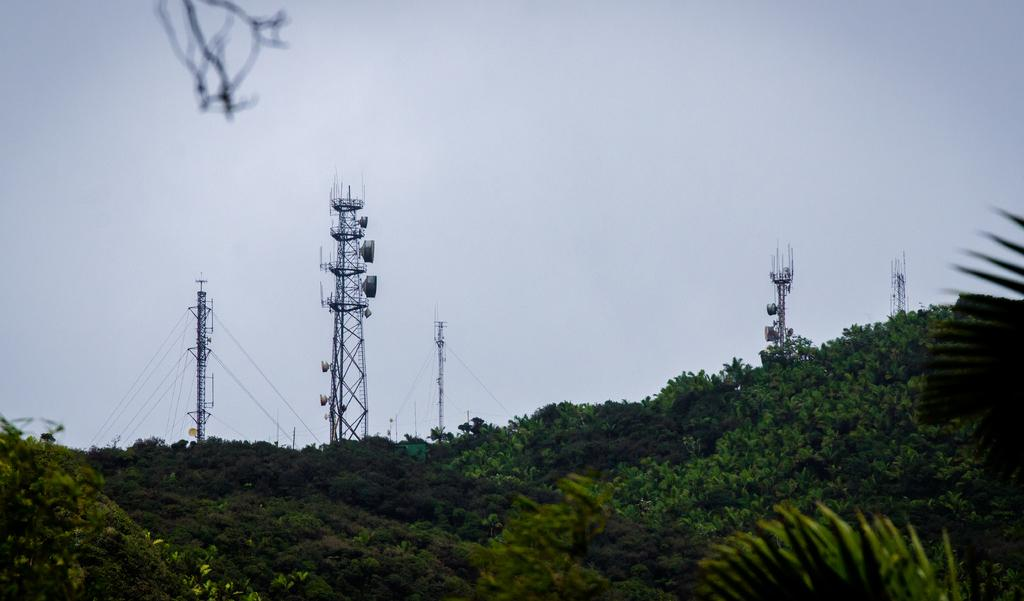What type of structures can be seen in the image? There are transmission towers in the image. What is connected to the transmission towers? There are electric wires in the image. What type of natural elements are visible in the image? There are trees visible in the image. What is visible in the background of the image? The sky is visible in the image. How many friends are sitting on the fireman's temper in the image? There are no friends or firemen present in the image. 